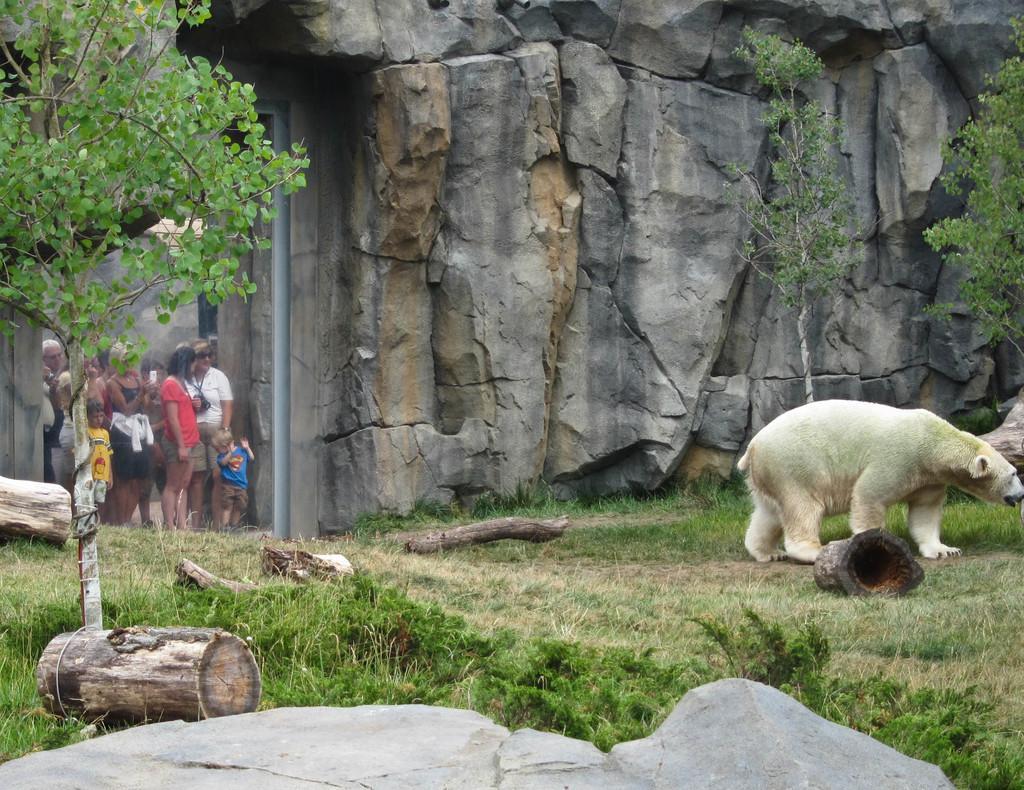Please provide a concise description of this image. In this picture we can see a polar bear, wooden logs, trees on the grass and in the background we can see a group of people, rocks. 